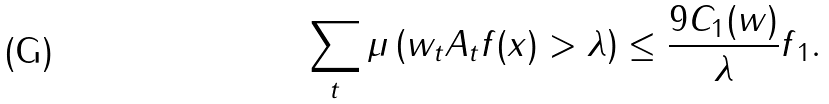Convert formula to latex. <formula><loc_0><loc_0><loc_500><loc_500>\sum _ { t } \mu \left ( w _ { t } A _ { t } f ( x ) > \lambda \right ) \leq \frac { 9 C _ { 1 } ( w ) } { \lambda } \| f \| _ { 1 } .</formula> 